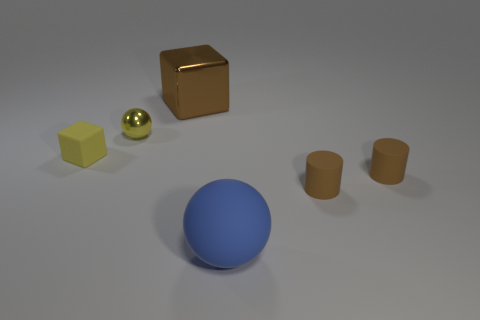The thing that is both left of the large cube and in front of the small yellow metallic ball has what shape? cube 